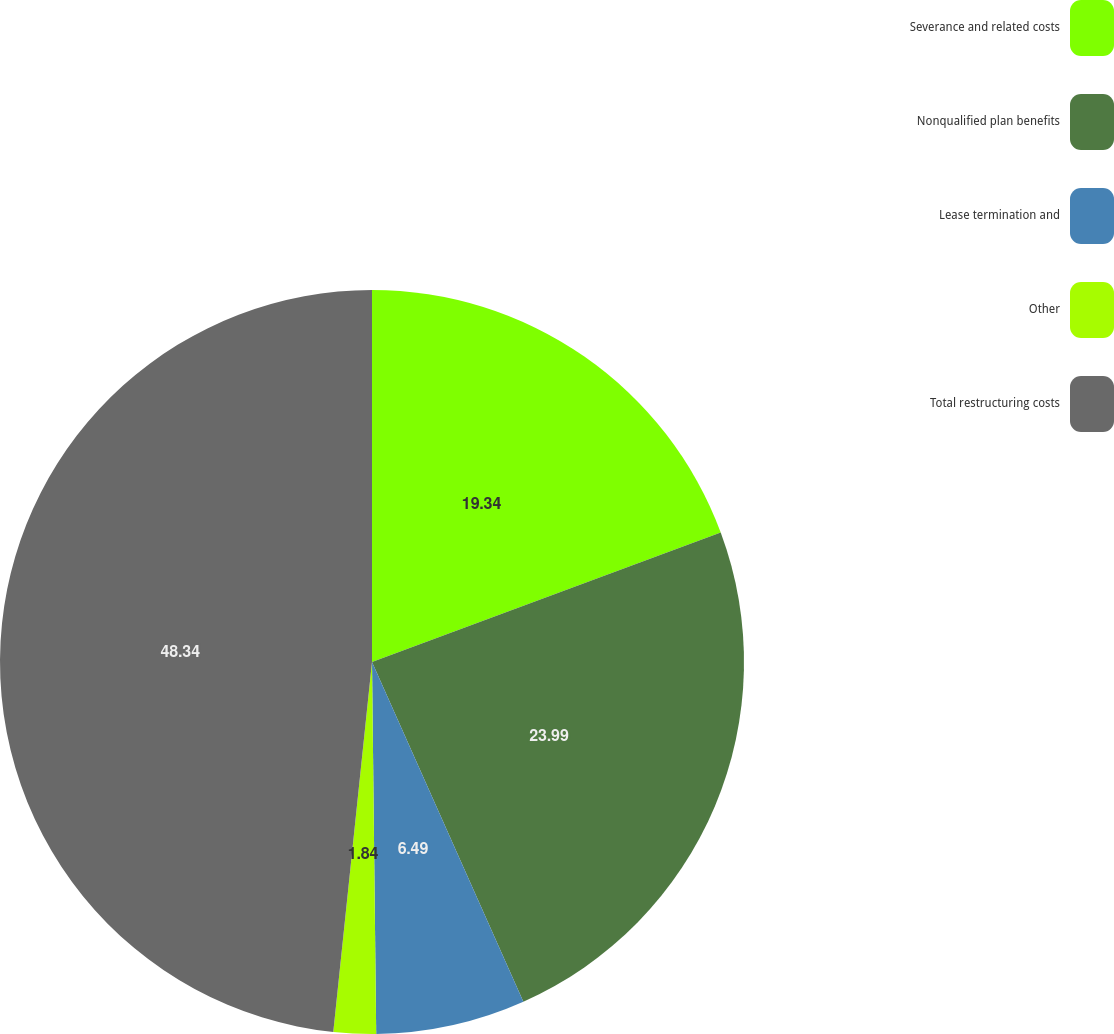<chart> <loc_0><loc_0><loc_500><loc_500><pie_chart><fcel>Severance and related costs<fcel>Nonqualified plan benefits<fcel>Lease termination and<fcel>Other<fcel>Total restructuring costs<nl><fcel>19.34%<fcel>23.99%<fcel>6.49%<fcel>1.84%<fcel>48.34%<nl></chart> 